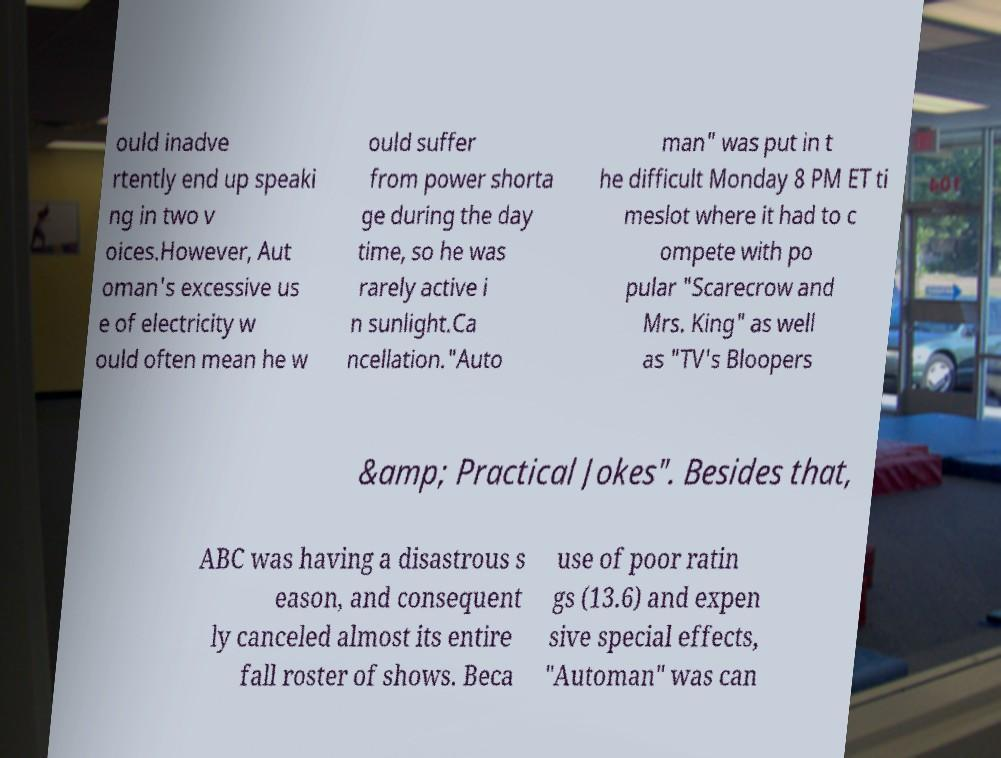Could you extract and type out the text from this image? ould inadve rtently end up speaki ng in two v oices.However, Aut oman's excessive us e of electricity w ould often mean he w ould suffer from power shorta ge during the day time, so he was rarely active i n sunlight.Ca ncellation."Auto man" was put in t he difficult Monday 8 PM ET ti meslot where it had to c ompete with po pular "Scarecrow and Mrs. King" as well as "TV's Bloopers &amp; Practical Jokes". Besides that, ABC was having a disastrous s eason, and consequent ly canceled almost its entire fall roster of shows. Beca use of poor ratin gs (13.6) and expen sive special effects, "Automan" was can 